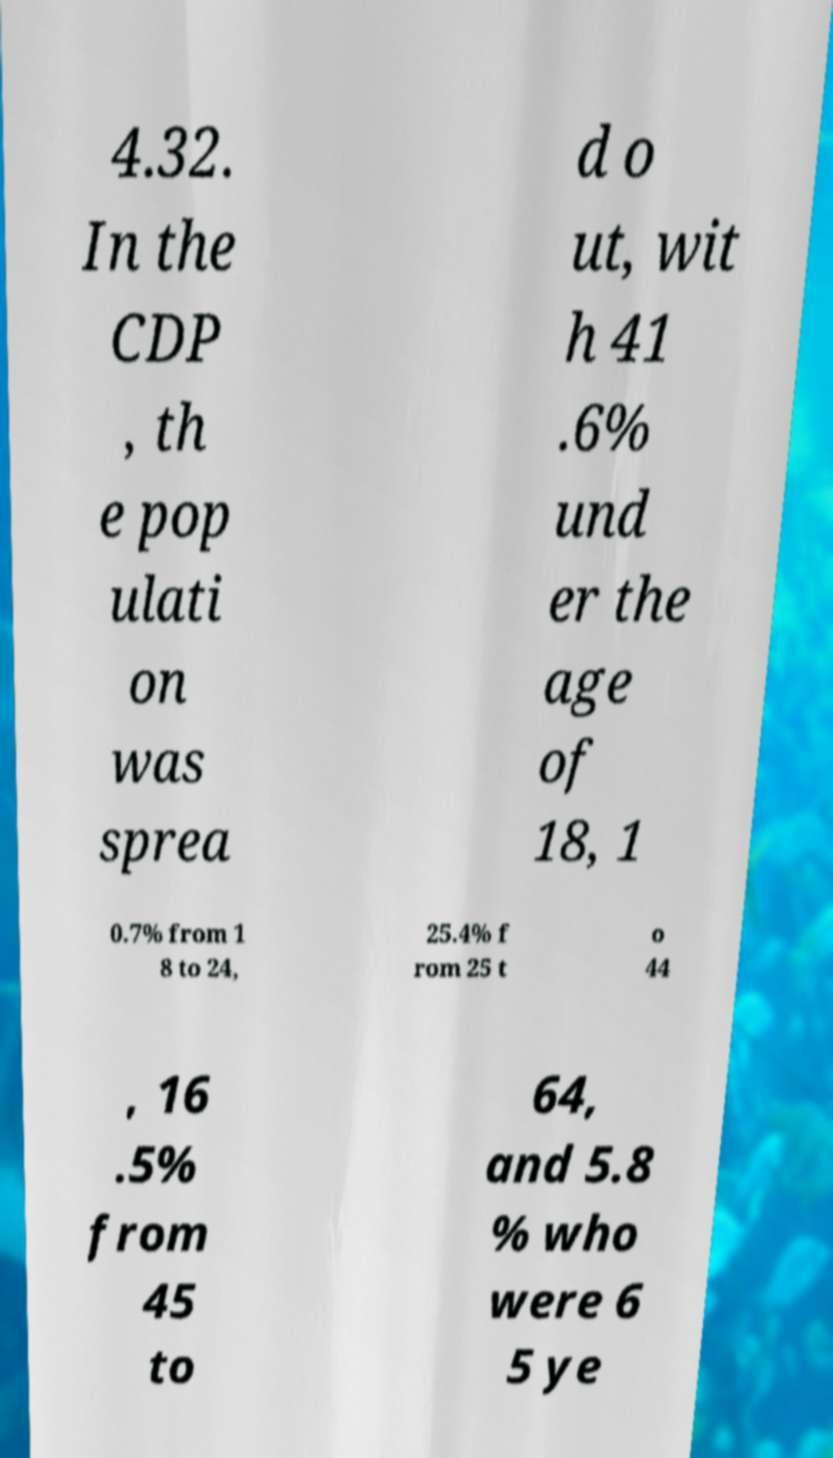Can you read and provide the text displayed in the image?This photo seems to have some interesting text. Can you extract and type it out for me? 4.32. In the CDP , th e pop ulati on was sprea d o ut, wit h 41 .6% und er the age of 18, 1 0.7% from 1 8 to 24, 25.4% f rom 25 t o 44 , 16 .5% from 45 to 64, and 5.8 % who were 6 5 ye 